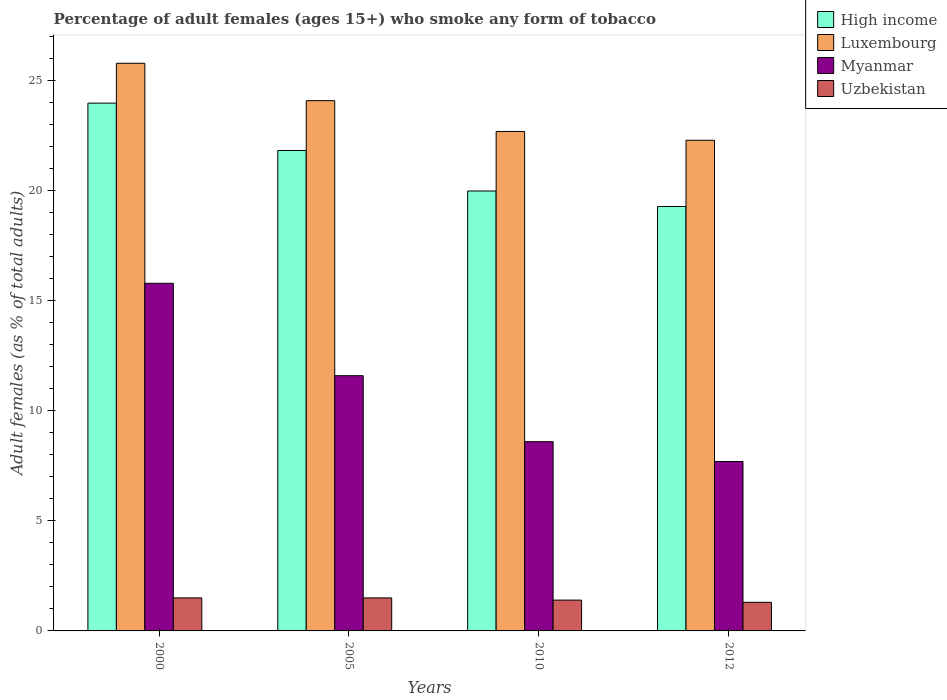Are the number of bars per tick equal to the number of legend labels?
Offer a very short reply. Yes. How many bars are there on the 2nd tick from the right?
Ensure brevity in your answer.  4. What is the label of the 2nd group of bars from the left?
Offer a terse response. 2005. In how many cases, is the number of bars for a given year not equal to the number of legend labels?
Your answer should be compact. 0. What is the percentage of adult females who smoke in High income in 2010?
Your answer should be compact. 19.99. In which year was the percentage of adult females who smoke in Myanmar minimum?
Provide a short and direct response. 2012. What is the total percentage of adult females who smoke in Myanmar in the graph?
Offer a very short reply. 43.7. What is the difference between the percentage of adult females who smoke in Luxembourg in 2000 and that in 2005?
Offer a terse response. 1.7. What is the average percentage of adult females who smoke in Uzbekistan per year?
Ensure brevity in your answer.  1.43. In the year 2000, what is the difference between the percentage of adult females who smoke in High income and percentage of adult females who smoke in Luxembourg?
Your response must be concise. -1.81. What is the ratio of the percentage of adult females who smoke in Myanmar in 2005 to that in 2010?
Your answer should be compact. 1.35. Is the percentage of adult females who smoke in Luxembourg in 2000 less than that in 2010?
Make the answer very short. No. Is the difference between the percentage of adult females who smoke in High income in 2000 and 2005 greater than the difference between the percentage of adult females who smoke in Luxembourg in 2000 and 2005?
Keep it short and to the point. Yes. What is the difference between the highest and the second highest percentage of adult females who smoke in Luxembourg?
Give a very brief answer. 1.7. What is the difference between the highest and the lowest percentage of adult females who smoke in Uzbekistan?
Your answer should be very brief. 0.2. In how many years, is the percentage of adult females who smoke in Uzbekistan greater than the average percentage of adult females who smoke in Uzbekistan taken over all years?
Offer a terse response. 2. Is the sum of the percentage of adult females who smoke in Luxembourg in 2000 and 2010 greater than the maximum percentage of adult females who smoke in Uzbekistan across all years?
Make the answer very short. Yes. Is it the case that in every year, the sum of the percentage of adult females who smoke in Luxembourg and percentage of adult females who smoke in Myanmar is greater than the sum of percentage of adult females who smoke in Uzbekistan and percentage of adult females who smoke in High income?
Provide a succinct answer. No. What does the 4th bar from the left in 2010 represents?
Your answer should be very brief. Uzbekistan. What does the 4th bar from the right in 2012 represents?
Your answer should be compact. High income. Is it the case that in every year, the sum of the percentage of adult females who smoke in High income and percentage of adult females who smoke in Myanmar is greater than the percentage of adult females who smoke in Uzbekistan?
Make the answer very short. Yes. How many bars are there?
Offer a terse response. 16. Are all the bars in the graph horizontal?
Provide a short and direct response. No. How many years are there in the graph?
Your response must be concise. 4. Are the values on the major ticks of Y-axis written in scientific E-notation?
Your answer should be compact. No. Where does the legend appear in the graph?
Your answer should be very brief. Top right. What is the title of the graph?
Your answer should be very brief. Percentage of adult females (ages 15+) who smoke any form of tobacco. Does "Bolivia" appear as one of the legend labels in the graph?
Ensure brevity in your answer.  No. What is the label or title of the X-axis?
Provide a succinct answer. Years. What is the label or title of the Y-axis?
Ensure brevity in your answer.  Adult females (as % of total adults). What is the Adult females (as % of total adults) of High income in 2000?
Your answer should be compact. 23.99. What is the Adult females (as % of total adults) of Luxembourg in 2000?
Your response must be concise. 25.8. What is the Adult females (as % of total adults) in Myanmar in 2000?
Your response must be concise. 15.8. What is the Adult females (as % of total adults) of Uzbekistan in 2000?
Offer a terse response. 1.5. What is the Adult females (as % of total adults) in High income in 2005?
Make the answer very short. 21.83. What is the Adult females (as % of total adults) of Luxembourg in 2005?
Keep it short and to the point. 24.1. What is the Adult females (as % of total adults) in Myanmar in 2005?
Keep it short and to the point. 11.6. What is the Adult females (as % of total adults) of Uzbekistan in 2005?
Give a very brief answer. 1.5. What is the Adult females (as % of total adults) of High income in 2010?
Offer a terse response. 19.99. What is the Adult females (as % of total adults) of Luxembourg in 2010?
Your answer should be compact. 22.7. What is the Adult females (as % of total adults) of Uzbekistan in 2010?
Provide a succinct answer. 1.4. What is the Adult females (as % of total adults) in High income in 2012?
Provide a short and direct response. 19.29. What is the Adult females (as % of total adults) of Luxembourg in 2012?
Your response must be concise. 22.3. What is the Adult females (as % of total adults) in Myanmar in 2012?
Provide a short and direct response. 7.7. What is the Adult females (as % of total adults) in Uzbekistan in 2012?
Provide a succinct answer. 1.3. Across all years, what is the maximum Adult females (as % of total adults) of High income?
Your answer should be compact. 23.99. Across all years, what is the maximum Adult females (as % of total adults) of Luxembourg?
Your answer should be compact. 25.8. Across all years, what is the maximum Adult females (as % of total adults) in Uzbekistan?
Your answer should be compact. 1.5. Across all years, what is the minimum Adult females (as % of total adults) of High income?
Provide a short and direct response. 19.29. Across all years, what is the minimum Adult females (as % of total adults) of Luxembourg?
Your answer should be compact. 22.3. Across all years, what is the minimum Adult females (as % of total adults) of Myanmar?
Keep it short and to the point. 7.7. Across all years, what is the minimum Adult females (as % of total adults) of Uzbekistan?
Ensure brevity in your answer.  1.3. What is the total Adult females (as % of total adults) of High income in the graph?
Your answer should be very brief. 85.11. What is the total Adult females (as % of total adults) of Luxembourg in the graph?
Make the answer very short. 94.9. What is the total Adult females (as % of total adults) in Myanmar in the graph?
Give a very brief answer. 43.7. What is the difference between the Adult females (as % of total adults) of High income in 2000 and that in 2005?
Offer a very short reply. 2.15. What is the difference between the Adult females (as % of total adults) of Myanmar in 2000 and that in 2005?
Offer a very short reply. 4.2. What is the difference between the Adult females (as % of total adults) in High income in 2000 and that in 2010?
Give a very brief answer. 3.99. What is the difference between the Adult females (as % of total adults) of High income in 2000 and that in 2012?
Offer a very short reply. 4.7. What is the difference between the Adult females (as % of total adults) in High income in 2005 and that in 2010?
Offer a very short reply. 1.84. What is the difference between the Adult females (as % of total adults) of Luxembourg in 2005 and that in 2010?
Your answer should be very brief. 1.4. What is the difference between the Adult females (as % of total adults) of Myanmar in 2005 and that in 2010?
Your answer should be very brief. 3. What is the difference between the Adult females (as % of total adults) of Uzbekistan in 2005 and that in 2010?
Provide a succinct answer. 0.1. What is the difference between the Adult females (as % of total adults) in High income in 2005 and that in 2012?
Provide a succinct answer. 2.54. What is the difference between the Adult females (as % of total adults) in Luxembourg in 2005 and that in 2012?
Ensure brevity in your answer.  1.8. What is the difference between the Adult females (as % of total adults) in High income in 2010 and that in 2012?
Provide a short and direct response. 0.7. What is the difference between the Adult females (as % of total adults) of Luxembourg in 2010 and that in 2012?
Provide a short and direct response. 0.4. What is the difference between the Adult females (as % of total adults) in High income in 2000 and the Adult females (as % of total adults) in Luxembourg in 2005?
Offer a very short reply. -0.11. What is the difference between the Adult females (as % of total adults) in High income in 2000 and the Adult females (as % of total adults) in Myanmar in 2005?
Provide a short and direct response. 12.39. What is the difference between the Adult females (as % of total adults) in High income in 2000 and the Adult females (as % of total adults) in Uzbekistan in 2005?
Provide a succinct answer. 22.49. What is the difference between the Adult females (as % of total adults) in Luxembourg in 2000 and the Adult females (as % of total adults) in Uzbekistan in 2005?
Your answer should be compact. 24.3. What is the difference between the Adult females (as % of total adults) of High income in 2000 and the Adult females (as % of total adults) of Luxembourg in 2010?
Provide a succinct answer. 1.29. What is the difference between the Adult females (as % of total adults) in High income in 2000 and the Adult females (as % of total adults) in Myanmar in 2010?
Ensure brevity in your answer.  15.39. What is the difference between the Adult females (as % of total adults) of High income in 2000 and the Adult females (as % of total adults) of Uzbekistan in 2010?
Your answer should be very brief. 22.59. What is the difference between the Adult females (as % of total adults) in Luxembourg in 2000 and the Adult females (as % of total adults) in Uzbekistan in 2010?
Provide a succinct answer. 24.4. What is the difference between the Adult females (as % of total adults) of High income in 2000 and the Adult females (as % of total adults) of Luxembourg in 2012?
Keep it short and to the point. 1.69. What is the difference between the Adult females (as % of total adults) in High income in 2000 and the Adult females (as % of total adults) in Myanmar in 2012?
Keep it short and to the point. 16.29. What is the difference between the Adult females (as % of total adults) in High income in 2000 and the Adult females (as % of total adults) in Uzbekistan in 2012?
Keep it short and to the point. 22.69. What is the difference between the Adult females (as % of total adults) in Myanmar in 2000 and the Adult females (as % of total adults) in Uzbekistan in 2012?
Make the answer very short. 14.5. What is the difference between the Adult females (as % of total adults) of High income in 2005 and the Adult females (as % of total adults) of Luxembourg in 2010?
Your answer should be compact. -0.87. What is the difference between the Adult females (as % of total adults) of High income in 2005 and the Adult females (as % of total adults) of Myanmar in 2010?
Give a very brief answer. 13.23. What is the difference between the Adult females (as % of total adults) in High income in 2005 and the Adult females (as % of total adults) in Uzbekistan in 2010?
Your answer should be compact. 20.43. What is the difference between the Adult females (as % of total adults) in Luxembourg in 2005 and the Adult females (as % of total adults) in Uzbekistan in 2010?
Offer a terse response. 22.7. What is the difference between the Adult females (as % of total adults) of High income in 2005 and the Adult females (as % of total adults) of Luxembourg in 2012?
Your answer should be compact. -0.47. What is the difference between the Adult females (as % of total adults) of High income in 2005 and the Adult females (as % of total adults) of Myanmar in 2012?
Your answer should be compact. 14.13. What is the difference between the Adult females (as % of total adults) in High income in 2005 and the Adult females (as % of total adults) in Uzbekistan in 2012?
Make the answer very short. 20.53. What is the difference between the Adult females (as % of total adults) in Luxembourg in 2005 and the Adult females (as % of total adults) in Myanmar in 2012?
Your response must be concise. 16.4. What is the difference between the Adult females (as % of total adults) in Luxembourg in 2005 and the Adult females (as % of total adults) in Uzbekistan in 2012?
Ensure brevity in your answer.  22.8. What is the difference between the Adult females (as % of total adults) in Myanmar in 2005 and the Adult females (as % of total adults) in Uzbekistan in 2012?
Make the answer very short. 10.3. What is the difference between the Adult females (as % of total adults) in High income in 2010 and the Adult females (as % of total adults) in Luxembourg in 2012?
Your answer should be very brief. -2.31. What is the difference between the Adult females (as % of total adults) of High income in 2010 and the Adult females (as % of total adults) of Myanmar in 2012?
Ensure brevity in your answer.  12.29. What is the difference between the Adult females (as % of total adults) of High income in 2010 and the Adult females (as % of total adults) of Uzbekistan in 2012?
Your answer should be very brief. 18.69. What is the difference between the Adult females (as % of total adults) in Luxembourg in 2010 and the Adult females (as % of total adults) in Uzbekistan in 2012?
Make the answer very short. 21.4. What is the average Adult females (as % of total adults) in High income per year?
Keep it short and to the point. 21.28. What is the average Adult females (as % of total adults) in Luxembourg per year?
Give a very brief answer. 23.73. What is the average Adult females (as % of total adults) in Myanmar per year?
Offer a terse response. 10.93. What is the average Adult females (as % of total adults) of Uzbekistan per year?
Your answer should be compact. 1.43. In the year 2000, what is the difference between the Adult females (as % of total adults) of High income and Adult females (as % of total adults) of Luxembourg?
Your response must be concise. -1.81. In the year 2000, what is the difference between the Adult females (as % of total adults) of High income and Adult females (as % of total adults) of Myanmar?
Give a very brief answer. 8.19. In the year 2000, what is the difference between the Adult females (as % of total adults) in High income and Adult females (as % of total adults) in Uzbekistan?
Offer a terse response. 22.49. In the year 2000, what is the difference between the Adult females (as % of total adults) in Luxembourg and Adult females (as % of total adults) in Uzbekistan?
Offer a terse response. 24.3. In the year 2000, what is the difference between the Adult females (as % of total adults) in Myanmar and Adult females (as % of total adults) in Uzbekistan?
Provide a succinct answer. 14.3. In the year 2005, what is the difference between the Adult females (as % of total adults) of High income and Adult females (as % of total adults) of Luxembourg?
Give a very brief answer. -2.27. In the year 2005, what is the difference between the Adult females (as % of total adults) in High income and Adult females (as % of total adults) in Myanmar?
Give a very brief answer. 10.23. In the year 2005, what is the difference between the Adult females (as % of total adults) of High income and Adult females (as % of total adults) of Uzbekistan?
Make the answer very short. 20.33. In the year 2005, what is the difference between the Adult females (as % of total adults) of Luxembourg and Adult females (as % of total adults) of Myanmar?
Provide a succinct answer. 12.5. In the year 2005, what is the difference between the Adult females (as % of total adults) in Luxembourg and Adult females (as % of total adults) in Uzbekistan?
Keep it short and to the point. 22.6. In the year 2005, what is the difference between the Adult females (as % of total adults) of Myanmar and Adult females (as % of total adults) of Uzbekistan?
Your answer should be very brief. 10.1. In the year 2010, what is the difference between the Adult females (as % of total adults) of High income and Adult females (as % of total adults) of Luxembourg?
Provide a short and direct response. -2.71. In the year 2010, what is the difference between the Adult females (as % of total adults) in High income and Adult females (as % of total adults) in Myanmar?
Make the answer very short. 11.39. In the year 2010, what is the difference between the Adult females (as % of total adults) of High income and Adult females (as % of total adults) of Uzbekistan?
Give a very brief answer. 18.59. In the year 2010, what is the difference between the Adult females (as % of total adults) in Luxembourg and Adult females (as % of total adults) in Myanmar?
Provide a succinct answer. 14.1. In the year 2010, what is the difference between the Adult females (as % of total adults) of Luxembourg and Adult females (as % of total adults) of Uzbekistan?
Provide a short and direct response. 21.3. In the year 2012, what is the difference between the Adult females (as % of total adults) in High income and Adult females (as % of total adults) in Luxembourg?
Make the answer very short. -3.01. In the year 2012, what is the difference between the Adult females (as % of total adults) in High income and Adult females (as % of total adults) in Myanmar?
Offer a terse response. 11.59. In the year 2012, what is the difference between the Adult females (as % of total adults) in High income and Adult females (as % of total adults) in Uzbekistan?
Offer a terse response. 17.99. In the year 2012, what is the difference between the Adult females (as % of total adults) in Myanmar and Adult females (as % of total adults) in Uzbekistan?
Give a very brief answer. 6.4. What is the ratio of the Adult females (as % of total adults) in High income in 2000 to that in 2005?
Keep it short and to the point. 1.1. What is the ratio of the Adult females (as % of total adults) of Luxembourg in 2000 to that in 2005?
Offer a very short reply. 1.07. What is the ratio of the Adult females (as % of total adults) of Myanmar in 2000 to that in 2005?
Your answer should be compact. 1.36. What is the ratio of the Adult females (as % of total adults) in High income in 2000 to that in 2010?
Your response must be concise. 1.2. What is the ratio of the Adult females (as % of total adults) of Luxembourg in 2000 to that in 2010?
Give a very brief answer. 1.14. What is the ratio of the Adult females (as % of total adults) of Myanmar in 2000 to that in 2010?
Keep it short and to the point. 1.84. What is the ratio of the Adult females (as % of total adults) in Uzbekistan in 2000 to that in 2010?
Make the answer very short. 1.07. What is the ratio of the Adult females (as % of total adults) in High income in 2000 to that in 2012?
Your answer should be very brief. 1.24. What is the ratio of the Adult females (as % of total adults) in Luxembourg in 2000 to that in 2012?
Offer a terse response. 1.16. What is the ratio of the Adult females (as % of total adults) of Myanmar in 2000 to that in 2012?
Ensure brevity in your answer.  2.05. What is the ratio of the Adult females (as % of total adults) of Uzbekistan in 2000 to that in 2012?
Ensure brevity in your answer.  1.15. What is the ratio of the Adult females (as % of total adults) of High income in 2005 to that in 2010?
Offer a terse response. 1.09. What is the ratio of the Adult females (as % of total adults) in Luxembourg in 2005 to that in 2010?
Your answer should be very brief. 1.06. What is the ratio of the Adult females (as % of total adults) of Myanmar in 2005 to that in 2010?
Give a very brief answer. 1.35. What is the ratio of the Adult females (as % of total adults) in Uzbekistan in 2005 to that in 2010?
Offer a very short reply. 1.07. What is the ratio of the Adult females (as % of total adults) of High income in 2005 to that in 2012?
Provide a short and direct response. 1.13. What is the ratio of the Adult females (as % of total adults) of Luxembourg in 2005 to that in 2012?
Your response must be concise. 1.08. What is the ratio of the Adult females (as % of total adults) of Myanmar in 2005 to that in 2012?
Give a very brief answer. 1.51. What is the ratio of the Adult females (as % of total adults) of Uzbekistan in 2005 to that in 2012?
Offer a very short reply. 1.15. What is the ratio of the Adult females (as % of total adults) of High income in 2010 to that in 2012?
Your response must be concise. 1.04. What is the ratio of the Adult females (as % of total adults) in Luxembourg in 2010 to that in 2012?
Keep it short and to the point. 1.02. What is the ratio of the Adult females (as % of total adults) in Myanmar in 2010 to that in 2012?
Your answer should be very brief. 1.12. What is the ratio of the Adult females (as % of total adults) of Uzbekistan in 2010 to that in 2012?
Offer a very short reply. 1.08. What is the difference between the highest and the second highest Adult females (as % of total adults) of High income?
Keep it short and to the point. 2.15. What is the difference between the highest and the second highest Adult females (as % of total adults) in Uzbekistan?
Offer a terse response. 0. What is the difference between the highest and the lowest Adult females (as % of total adults) in High income?
Your answer should be very brief. 4.7. What is the difference between the highest and the lowest Adult females (as % of total adults) in Luxembourg?
Give a very brief answer. 3.5. What is the difference between the highest and the lowest Adult females (as % of total adults) in Uzbekistan?
Keep it short and to the point. 0.2. 